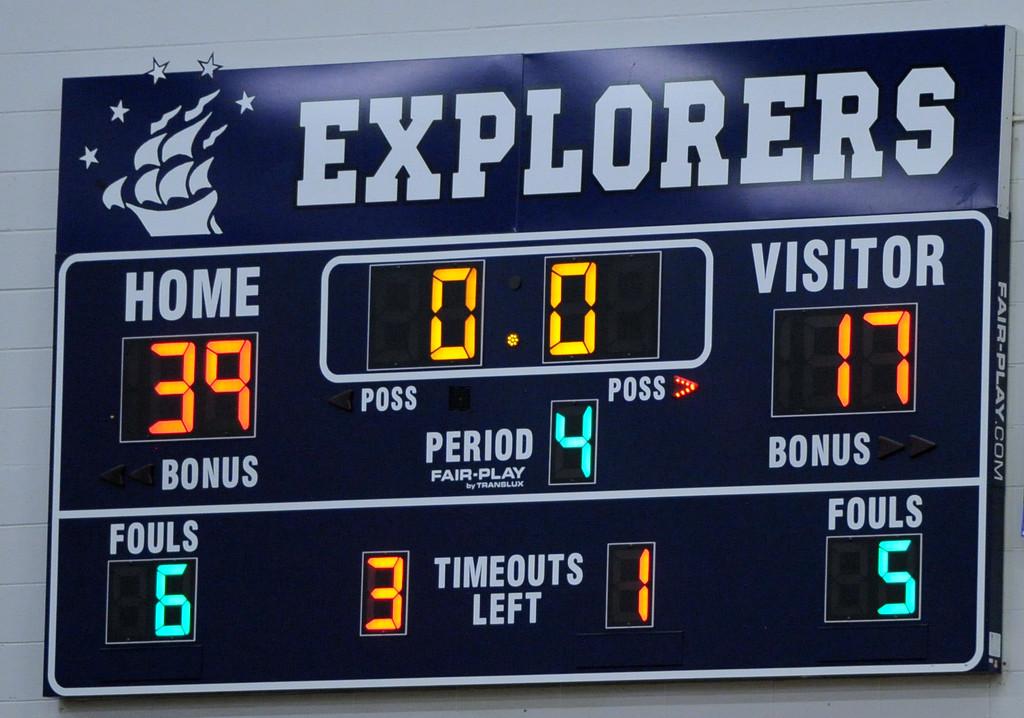What is the score of the game?
Ensure brevity in your answer.  39-17. What period is it?
Make the answer very short. 4. 